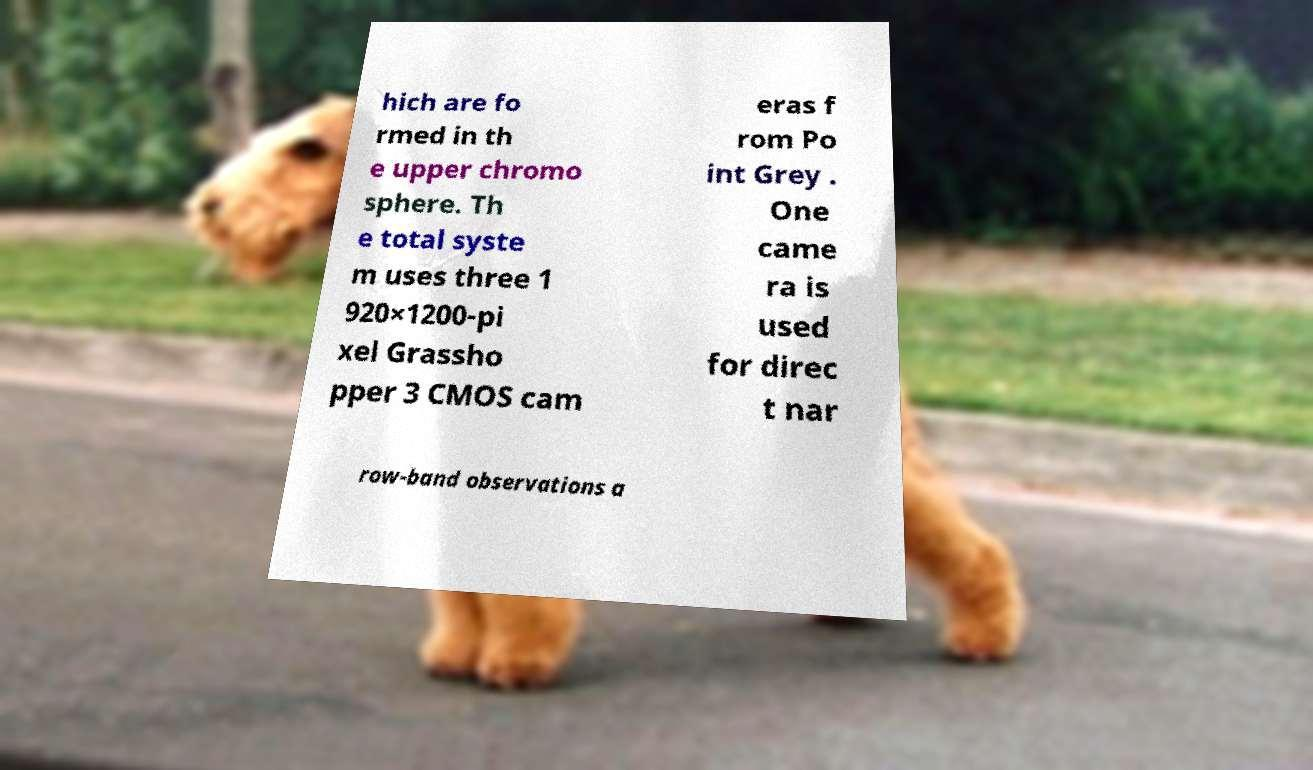There's text embedded in this image that I need extracted. Can you transcribe it verbatim? hich are fo rmed in th e upper chromo sphere. Th e total syste m uses three 1 920×1200-pi xel Grassho pper 3 CMOS cam eras f rom Po int Grey . One came ra is used for direc t nar row-band observations a 